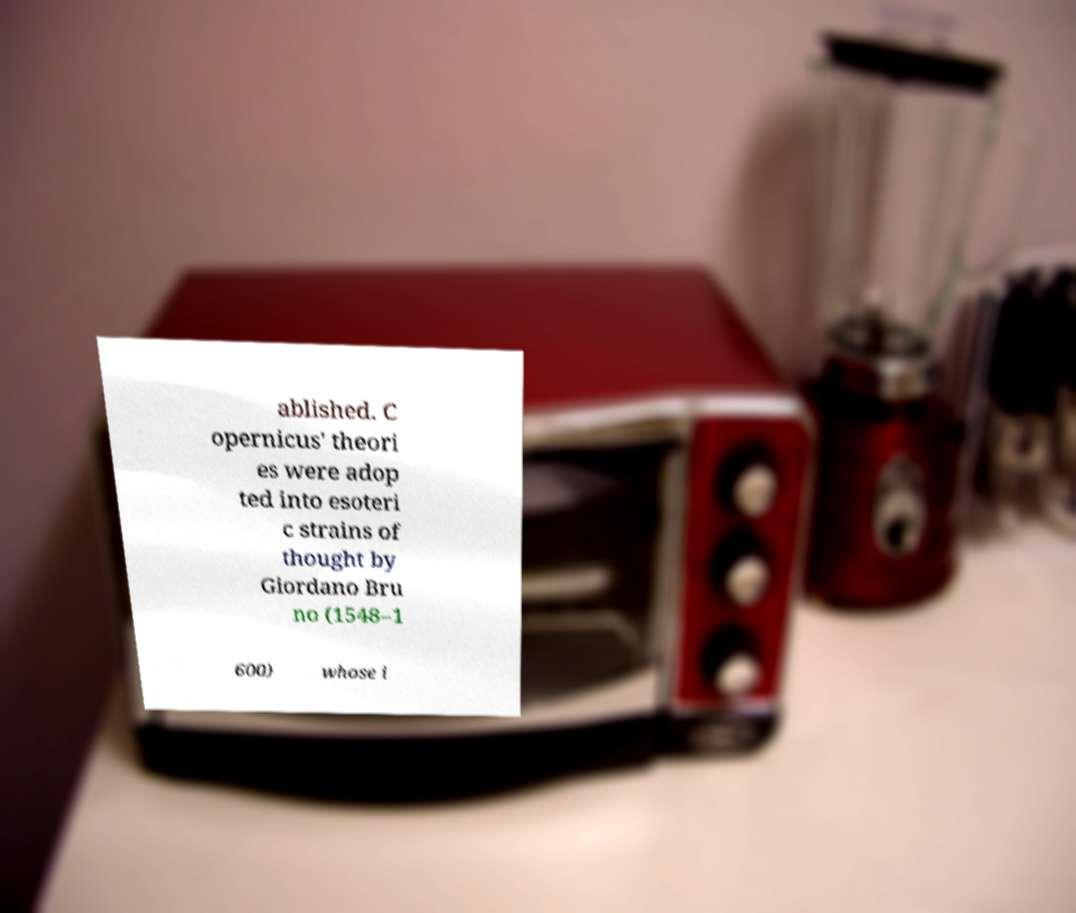Can you accurately transcribe the text from the provided image for me? ablished. C opernicus' theori es were adop ted into esoteri c strains of thought by Giordano Bru no (1548–1 600) whose i 